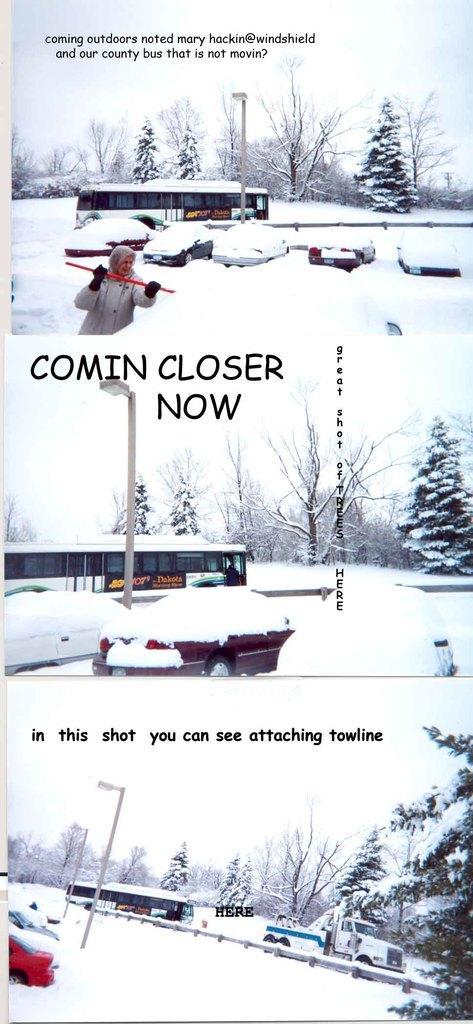How would you summarize this image in a sentence or two? This is a collage image. In this image we can see ground covered with snow, motor vehicles, trees, woman holding a shovel in her hand, street pole, street light, barriers and sky. 